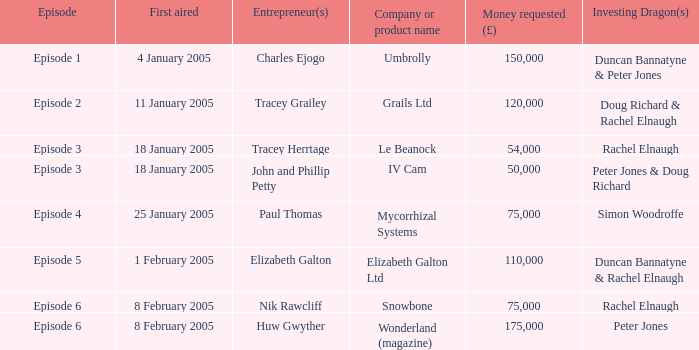Who were the investing dragons in the episode that initially broadcasted on 18 january 2005 featuring the entrepreneur tracey herrtage? Rachel Elnaugh. 